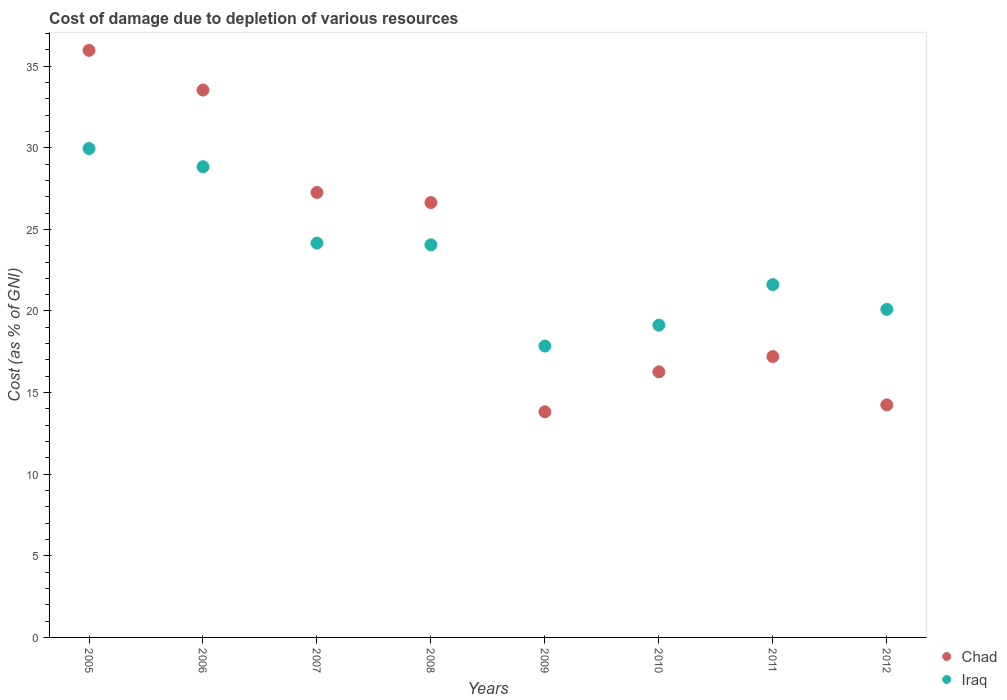Is the number of dotlines equal to the number of legend labels?
Keep it short and to the point. Yes. What is the cost of damage caused due to the depletion of various resources in Chad in 2005?
Your response must be concise. 35.97. Across all years, what is the maximum cost of damage caused due to the depletion of various resources in Iraq?
Your answer should be very brief. 29.95. Across all years, what is the minimum cost of damage caused due to the depletion of various resources in Chad?
Your answer should be very brief. 13.82. What is the total cost of damage caused due to the depletion of various resources in Chad in the graph?
Ensure brevity in your answer.  184.96. What is the difference between the cost of damage caused due to the depletion of various resources in Iraq in 2005 and that in 2006?
Provide a short and direct response. 1.12. What is the difference between the cost of damage caused due to the depletion of various resources in Iraq in 2011 and the cost of damage caused due to the depletion of various resources in Chad in 2007?
Offer a very short reply. -5.64. What is the average cost of damage caused due to the depletion of various resources in Chad per year?
Your response must be concise. 23.12. In the year 2005, what is the difference between the cost of damage caused due to the depletion of various resources in Iraq and cost of damage caused due to the depletion of various resources in Chad?
Ensure brevity in your answer.  -6.02. In how many years, is the cost of damage caused due to the depletion of various resources in Iraq greater than 20 %?
Offer a very short reply. 6. What is the ratio of the cost of damage caused due to the depletion of various resources in Chad in 2009 to that in 2011?
Give a very brief answer. 0.8. Is the cost of damage caused due to the depletion of various resources in Iraq in 2006 less than that in 2012?
Your response must be concise. No. What is the difference between the highest and the second highest cost of damage caused due to the depletion of various resources in Iraq?
Your answer should be very brief. 1.12. What is the difference between the highest and the lowest cost of damage caused due to the depletion of various resources in Iraq?
Provide a short and direct response. 12.1. In how many years, is the cost of damage caused due to the depletion of various resources in Iraq greater than the average cost of damage caused due to the depletion of various resources in Iraq taken over all years?
Your answer should be very brief. 4. Is the sum of the cost of damage caused due to the depletion of various resources in Chad in 2007 and 2009 greater than the maximum cost of damage caused due to the depletion of various resources in Iraq across all years?
Make the answer very short. Yes. Is the cost of damage caused due to the depletion of various resources in Chad strictly less than the cost of damage caused due to the depletion of various resources in Iraq over the years?
Keep it short and to the point. No. How many dotlines are there?
Your answer should be compact. 2. How many years are there in the graph?
Make the answer very short. 8. What is the difference between two consecutive major ticks on the Y-axis?
Your answer should be compact. 5. Are the values on the major ticks of Y-axis written in scientific E-notation?
Offer a very short reply. No. Where does the legend appear in the graph?
Give a very brief answer. Bottom right. How many legend labels are there?
Your response must be concise. 2. What is the title of the graph?
Your answer should be compact. Cost of damage due to depletion of various resources. Does "Morocco" appear as one of the legend labels in the graph?
Make the answer very short. No. What is the label or title of the X-axis?
Your answer should be compact. Years. What is the label or title of the Y-axis?
Your answer should be compact. Cost (as % of GNI). What is the Cost (as % of GNI) in Chad in 2005?
Provide a short and direct response. 35.97. What is the Cost (as % of GNI) of Iraq in 2005?
Offer a very short reply. 29.95. What is the Cost (as % of GNI) of Chad in 2006?
Keep it short and to the point. 33.53. What is the Cost (as % of GNI) in Iraq in 2006?
Provide a succinct answer. 28.84. What is the Cost (as % of GNI) of Chad in 2007?
Offer a very short reply. 27.26. What is the Cost (as % of GNI) in Iraq in 2007?
Make the answer very short. 24.16. What is the Cost (as % of GNI) in Chad in 2008?
Keep it short and to the point. 26.64. What is the Cost (as % of GNI) of Iraq in 2008?
Give a very brief answer. 24.06. What is the Cost (as % of GNI) in Chad in 2009?
Offer a terse response. 13.82. What is the Cost (as % of GNI) of Iraq in 2009?
Your answer should be compact. 17.85. What is the Cost (as % of GNI) in Chad in 2010?
Your response must be concise. 16.27. What is the Cost (as % of GNI) of Iraq in 2010?
Your answer should be compact. 19.13. What is the Cost (as % of GNI) of Chad in 2011?
Your response must be concise. 17.21. What is the Cost (as % of GNI) of Iraq in 2011?
Give a very brief answer. 21.62. What is the Cost (as % of GNI) in Chad in 2012?
Offer a very short reply. 14.25. What is the Cost (as % of GNI) in Iraq in 2012?
Give a very brief answer. 20.1. Across all years, what is the maximum Cost (as % of GNI) of Chad?
Offer a very short reply. 35.97. Across all years, what is the maximum Cost (as % of GNI) of Iraq?
Offer a terse response. 29.95. Across all years, what is the minimum Cost (as % of GNI) of Chad?
Make the answer very short. 13.82. Across all years, what is the minimum Cost (as % of GNI) of Iraq?
Provide a succinct answer. 17.85. What is the total Cost (as % of GNI) in Chad in the graph?
Your answer should be very brief. 184.96. What is the total Cost (as % of GNI) of Iraq in the graph?
Your answer should be compact. 185.71. What is the difference between the Cost (as % of GNI) of Chad in 2005 and that in 2006?
Make the answer very short. 2.43. What is the difference between the Cost (as % of GNI) in Iraq in 2005 and that in 2006?
Your answer should be compact. 1.12. What is the difference between the Cost (as % of GNI) in Chad in 2005 and that in 2007?
Your response must be concise. 8.71. What is the difference between the Cost (as % of GNI) of Iraq in 2005 and that in 2007?
Your answer should be compact. 5.79. What is the difference between the Cost (as % of GNI) of Chad in 2005 and that in 2008?
Your response must be concise. 9.33. What is the difference between the Cost (as % of GNI) in Iraq in 2005 and that in 2008?
Provide a short and direct response. 5.9. What is the difference between the Cost (as % of GNI) of Chad in 2005 and that in 2009?
Your response must be concise. 22.15. What is the difference between the Cost (as % of GNI) in Iraq in 2005 and that in 2009?
Your answer should be very brief. 12.1. What is the difference between the Cost (as % of GNI) in Chad in 2005 and that in 2010?
Provide a short and direct response. 19.7. What is the difference between the Cost (as % of GNI) in Iraq in 2005 and that in 2010?
Give a very brief answer. 10.82. What is the difference between the Cost (as % of GNI) of Chad in 2005 and that in 2011?
Keep it short and to the point. 18.76. What is the difference between the Cost (as % of GNI) in Iraq in 2005 and that in 2011?
Provide a short and direct response. 8.34. What is the difference between the Cost (as % of GNI) of Chad in 2005 and that in 2012?
Make the answer very short. 21.72. What is the difference between the Cost (as % of GNI) in Iraq in 2005 and that in 2012?
Make the answer very short. 9.85. What is the difference between the Cost (as % of GNI) in Chad in 2006 and that in 2007?
Keep it short and to the point. 6.27. What is the difference between the Cost (as % of GNI) of Iraq in 2006 and that in 2007?
Ensure brevity in your answer.  4.68. What is the difference between the Cost (as % of GNI) of Chad in 2006 and that in 2008?
Provide a succinct answer. 6.89. What is the difference between the Cost (as % of GNI) in Iraq in 2006 and that in 2008?
Offer a very short reply. 4.78. What is the difference between the Cost (as % of GNI) of Chad in 2006 and that in 2009?
Offer a terse response. 19.71. What is the difference between the Cost (as % of GNI) of Iraq in 2006 and that in 2009?
Make the answer very short. 10.99. What is the difference between the Cost (as % of GNI) of Chad in 2006 and that in 2010?
Ensure brevity in your answer.  17.26. What is the difference between the Cost (as % of GNI) of Iraq in 2006 and that in 2010?
Offer a terse response. 9.71. What is the difference between the Cost (as % of GNI) of Chad in 2006 and that in 2011?
Offer a very short reply. 16.33. What is the difference between the Cost (as % of GNI) of Iraq in 2006 and that in 2011?
Your answer should be very brief. 7.22. What is the difference between the Cost (as % of GNI) in Chad in 2006 and that in 2012?
Provide a short and direct response. 19.29. What is the difference between the Cost (as % of GNI) in Iraq in 2006 and that in 2012?
Give a very brief answer. 8.74. What is the difference between the Cost (as % of GNI) in Chad in 2007 and that in 2008?
Ensure brevity in your answer.  0.62. What is the difference between the Cost (as % of GNI) of Iraq in 2007 and that in 2008?
Your response must be concise. 0.11. What is the difference between the Cost (as % of GNI) in Chad in 2007 and that in 2009?
Ensure brevity in your answer.  13.44. What is the difference between the Cost (as % of GNI) in Iraq in 2007 and that in 2009?
Your answer should be compact. 6.31. What is the difference between the Cost (as % of GNI) in Chad in 2007 and that in 2010?
Your answer should be compact. 10.99. What is the difference between the Cost (as % of GNI) of Iraq in 2007 and that in 2010?
Your answer should be very brief. 5.03. What is the difference between the Cost (as % of GNI) in Chad in 2007 and that in 2011?
Your answer should be compact. 10.06. What is the difference between the Cost (as % of GNI) in Iraq in 2007 and that in 2011?
Offer a terse response. 2.54. What is the difference between the Cost (as % of GNI) of Chad in 2007 and that in 2012?
Offer a very short reply. 13.02. What is the difference between the Cost (as % of GNI) of Iraq in 2007 and that in 2012?
Your response must be concise. 4.06. What is the difference between the Cost (as % of GNI) of Chad in 2008 and that in 2009?
Offer a terse response. 12.82. What is the difference between the Cost (as % of GNI) in Iraq in 2008 and that in 2009?
Your answer should be very brief. 6.21. What is the difference between the Cost (as % of GNI) in Chad in 2008 and that in 2010?
Offer a terse response. 10.37. What is the difference between the Cost (as % of GNI) in Iraq in 2008 and that in 2010?
Offer a terse response. 4.93. What is the difference between the Cost (as % of GNI) of Chad in 2008 and that in 2011?
Give a very brief answer. 9.44. What is the difference between the Cost (as % of GNI) in Iraq in 2008 and that in 2011?
Provide a short and direct response. 2.44. What is the difference between the Cost (as % of GNI) of Chad in 2008 and that in 2012?
Ensure brevity in your answer.  12.4. What is the difference between the Cost (as % of GNI) of Iraq in 2008 and that in 2012?
Ensure brevity in your answer.  3.96. What is the difference between the Cost (as % of GNI) of Chad in 2009 and that in 2010?
Give a very brief answer. -2.45. What is the difference between the Cost (as % of GNI) of Iraq in 2009 and that in 2010?
Offer a very short reply. -1.28. What is the difference between the Cost (as % of GNI) of Chad in 2009 and that in 2011?
Your answer should be very brief. -3.38. What is the difference between the Cost (as % of GNI) of Iraq in 2009 and that in 2011?
Ensure brevity in your answer.  -3.77. What is the difference between the Cost (as % of GNI) of Chad in 2009 and that in 2012?
Offer a very short reply. -0.42. What is the difference between the Cost (as % of GNI) of Iraq in 2009 and that in 2012?
Offer a very short reply. -2.25. What is the difference between the Cost (as % of GNI) in Chad in 2010 and that in 2011?
Offer a very short reply. -0.94. What is the difference between the Cost (as % of GNI) of Iraq in 2010 and that in 2011?
Your answer should be very brief. -2.49. What is the difference between the Cost (as % of GNI) in Chad in 2010 and that in 2012?
Offer a terse response. 2.02. What is the difference between the Cost (as % of GNI) of Iraq in 2010 and that in 2012?
Keep it short and to the point. -0.97. What is the difference between the Cost (as % of GNI) of Chad in 2011 and that in 2012?
Keep it short and to the point. 2.96. What is the difference between the Cost (as % of GNI) of Iraq in 2011 and that in 2012?
Provide a succinct answer. 1.52. What is the difference between the Cost (as % of GNI) in Chad in 2005 and the Cost (as % of GNI) in Iraq in 2006?
Give a very brief answer. 7.13. What is the difference between the Cost (as % of GNI) in Chad in 2005 and the Cost (as % of GNI) in Iraq in 2007?
Provide a short and direct response. 11.81. What is the difference between the Cost (as % of GNI) in Chad in 2005 and the Cost (as % of GNI) in Iraq in 2008?
Offer a very short reply. 11.91. What is the difference between the Cost (as % of GNI) in Chad in 2005 and the Cost (as % of GNI) in Iraq in 2009?
Provide a short and direct response. 18.12. What is the difference between the Cost (as % of GNI) of Chad in 2005 and the Cost (as % of GNI) of Iraq in 2010?
Provide a succinct answer. 16.84. What is the difference between the Cost (as % of GNI) of Chad in 2005 and the Cost (as % of GNI) of Iraq in 2011?
Your response must be concise. 14.35. What is the difference between the Cost (as % of GNI) in Chad in 2005 and the Cost (as % of GNI) in Iraq in 2012?
Your answer should be compact. 15.87. What is the difference between the Cost (as % of GNI) in Chad in 2006 and the Cost (as % of GNI) in Iraq in 2007?
Your answer should be compact. 9.37. What is the difference between the Cost (as % of GNI) of Chad in 2006 and the Cost (as % of GNI) of Iraq in 2008?
Offer a terse response. 9.48. What is the difference between the Cost (as % of GNI) in Chad in 2006 and the Cost (as % of GNI) in Iraq in 2009?
Your response must be concise. 15.68. What is the difference between the Cost (as % of GNI) of Chad in 2006 and the Cost (as % of GNI) of Iraq in 2010?
Your response must be concise. 14.4. What is the difference between the Cost (as % of GNI) of Chad in 2006 and the Cost (as % of GNI) of Iraq in 2011?
Provide a succinct answer. 11.92. What is the difference between the Cost (as % of GNI) of Chad in 2006 and the Cost (as % of GNI) of Iraq in 2012?
Your response must be concise. 13.44. What is the difference between the Cost (as % of GNI) in Chad in 2007 and the Cost (as % of GNI) in Iraq in 2008?
Provide a succinct answer. 3.21. What is the difference between the Cost (as % of GNI) in Chad in 2007 and the Cost (as % of GNI) in Iraq in 2009?
Offer a very short reply. 9.41. What is the difference between the Cost (as % of GNI) of Chad in 2007 and the Cost (as % of GNI) of Iraq in 2010?
Offer a terse response. 8.13. What is the difference between the Cost (as % of GNI) of Chad in 2007 and the Cost (as % of GNI) of Iraq in 2011?
Offer a terse response. 5.64. What is the difference between the Cost (as % of GNI) of Chad in 2007 and the Cost (as % of GNI) of Iraq in 2012?
Offer a terse response. 7.16. What is the difference between the Cost (as % of GNI) of Chad in 2008 and the Cost (as % of GNI) of Iraq in 2009?
Provide a succinct answer. 8.79. What is the difference between the Cost (as % of GNI) of Chad in 2008 and the Cost (as % of GNI) of Iraq in 2010?
Your answer should be compact. 7.51. What is the difference between the Cost (as % of GNI) in Chad in 2008 and the Cost (as % of GNI) in Iraq in 2011?
Provide a succinct answer. 5.02. What is the difference between the Cost (as % of GNI) in Chad in 2008 and the Cost (as % of GNI) in Iraq in 2012?
Keep it short and to the point. 6.54. What is the difference between the Cost (as % of GNI) of Chad in 2009 and the Cost (as % of GNI) of Iraq in 2010?
Make the answer very short. -5.31. What is the difference between the Cost (as % of GNI) of Chad in 2009 and the Cost (as % of GNI) of Iraq in 2011?
Offer a terse response. -7.8. What is the difference between the Cost (as % of GNI) of Chad in 2009 and the Cost (as % of GNI) of Iraq in 2012?
Provide a succinct answer. -6.28. What is the difference between the Cost (as % of GNI) of Chad in 2010 and the Cost (as % of GNI) of Iraq in 2011?
Keep it short and to the point. -5.35. What is the difference between the Cost (as % of GNI) in Chad in 2010 and the Cost (as % of GNI) in Iraq in 2012?
Keep it short and to the point. -3.83. What is the difference between the Cost (as % of GNI) of Chad in 2011 and the Cost (as % of GNI) of Iraq in 2012?
Provide a succinct answer. -2.89. What is the average Cost (as % of GNI) of Chad per year?
Offer a very short reply. 23.12. What is the average Cost (as % of GNI) in Iraq per year?
Give a very brief answer. 23.21. In the year 2005, what is the difference between the Cost (as % of GNI) in Chad and Cost (as % of GNI) in Iraq?
Offer a terse response. 6.02. In the year 2006, what is the difference between the Cost (as % of GNI) in Chad and Cost (as % of GNI) in Iraq?
Provide a short and direct response. 4.7. In the year 2007, what is the difference between the Cost (as % of GNI) in Chad and Cost (as % of GNI) in Iraq?
Provide a short and direct response. 3.1. In the year 2008, what is the difference between the Cost (as % of GNI) of Chad and Cost (as % of GNI) of Iraq?
Your response must be concise. 2.59. In the year 2009, what is the difference between the Cost (as % of GNI) in Chad and Cost (as % of GNI) in Iraq?
Provide a succinct answer. -4.03. In the year 2010, what is the difference between the Cost (as % of GNI) of Chad and Cost (as % of GNI) of Iraq?
Provide a short and direct response. -2.86. In the year 2011, what is the difference between the Cost (as % of GNI) in Chad and Cost (as % of GNI) in Iraq?
Your answer should be compact. -4.41. In the year 2012, what is the difference between the Cost (as % of GNI) in Chad and Cost (as % of GNI) in Iraq?
Provide a succinct answer. -5.85. What is the ratio of the Cost (as % of GNI) in Chad in 2005 to that in 2006?
Offer a terse response. 1.07. What is the ratio of the Cost (as % of GNI) of Iraq in 2005 to that in 2006?
Your response must be concise. 1.04. What is the ratio of the Cost (as % of GNI) of Chad in 2005 to that in 2007?
Your answer should be very brief. 1.32. What is the ratio of the Cost (as % of GNI) of Iraq in 2005 to that in 2007?
Your response must be concise. 1.24. What is the ratio of the Cost (as % of GNI) of Chad in 2005 to that in 2008?
Offer a terse response. 1.35. What is the ratio of the Cost (as % of GNI) of Iraq in 2005 to that in 2008?
Give a very brief answer. 1.25. What is the ratio of the Cost (as % of GNI) in Chad in 2005 to that in 2009?
Your response must be concise. 2.6. What is the ratio of the Cost (as % of GNI) in Iraq in 2005 to that in 2009?
Ensure brevity in your answer.  1.68. What is the ratio of the Cost (as % of GNI) in Chad in 2005 to that in 2010?
Provide a succinct answer. 2.21. What is the ratio of the Cost (as % of GNI) of Iraq in 2005 to that in 2010?
Offer a terse response. 1.57. What is the ratio of the Cost (as % of GNI) in Chad in 2005 to that in 2011?
Give a very brief answer. 2.09. What is the ratio of the Cost (as % of GNI) of Iraq in 2005 to that in 2011?
Your answer should be very brief. 1.39. What is the ratio of the Cost (as % of GNI) of Chad in 2005 to that in 2012?
Your answer should be very brief. 2.52. What is the ratio of the Cost (as % of GNI) of Iraq in 2005 to that in 2012?
Your response must be concise. 1.49. What is the ratio of the Cost (as % of GNI) of Chad in 2006 to that in 2007?
Your answer should be compact. 1.23. What is the ratio of the Cost (as % of GNI) in Iraq in 2006 to that in 2007?
Your answer should be very brief. 1.19. What is the ratio of the Cost (as % of GNI) in Chad in 2006 to that in 2008?
Ensure brevity in your answer.  1.26. What is the ratio of the Cost (as % of GNI) in Iraq in 2006 to that in 2008?
Offer a terse response. 1.2. What is the ratio of the Cost (as % of GNI) in Chad in 2006 to that in 2009?
Make the answer very short. 2.43. What is the ratio of the Cost (as % of GNI) in Iraq in 2006 to that in 2009?
Ensure brevity in your answer.  1.62. What is the ratio of the Cost (as % of GNI) in Chad in 2006 to that in 2010?
Ensure brevity in your answer.  2.06. What is the ratio of the Cost (as % of GNI) of Iraq in 2006 to that in 2010?
Keep it short and to the point. 1.51. What is the ratio of the Cost (as % of GNI) of Chad in 2006 to that in 2011?
Your answer should be very brief. 1.95. What is the ratio of the Cost (as % of GNI) of Iraq in 2006 to that in 2011?
Give a very brief answer. 1.33. What is the ratio of the Cost (as % of GNI) in Chad in 2006 to that in 2012?
Make the answer very short. 2.35. What is the ratio of the Cost (as % of GNI) of Iraq in 2006 to that in 2012?
Your answer should be very brief. 1.43. What is the ratio of the Cost (as % of GNI) in Chad in 2007 to that in 2008?
Keep it short and to the point. 1.02. What is the ratio of the Cost (as % of GNI) in Iraq in 2007 to that in 2008?
Provide a succinct answer. 1. What is the ratio of the Cost (as % of GNI) in Chad in 2007 to that in 2009?
Your response must be concise. 1.97. What is the ratio of the Cost (as % of GNI) in Iraq in 2007 to that in 2009?
Offer a very short reply. 1.35. What is the ratio of the Cost (as % of GNI) of Chad in 2007 to that in 2010?
Offer a very short reply. 1.68. What is the ratio of the Cost (as % of GNI) in Iraq in 2007 to that in 2010?
Provide a succinct answer. 1.26. What is the ratio of the Cost (as % of GNI) in Chad in 2007 to that in 2011?
Offer a very short reply. 1.58. What is the ratio of the Cost (as % of GNI) in Iraq in 2007 to that in 2011?
Provide a short and direct response. 1.12. What is the ratio of the Cost (as % of GNI) of Chad in 2007 to that in 2012?
Your answer should be compact. 1.91. What is the ratio of the Cost (as % of GNI) of Iraq in 2007 to that in 2012?
Provide a succinct answer. 1.2. What is the ratio of the Cost (as % of GNI) in Chad in 2008 to that in 2009?
Your answer should be compact. 1.93. What is the ratio of the Cost (as % of GNI) in Iraq in 2008 to that in 2009?
Offer a very short reply. 1.35. What is the ratio of the Cost (as % of GNI) in Chad in 2008 to that in 2010?
Provide a succinct answer. 1.64. What is the ratio of the Cost (as % of GNI) in Iraq in 2008 to that in 2010?
Keep it short and to the point. 1.26. What is the ratio of the Cost (as % of GNI) of Chad in 2008 to that in 2011?
Make the answer very short. 1.55. What is the ratio of the Cost (as % of GNI) of Iraq in 2008 to that in 2011?
Offer a very short reply. 1.11. What is the ratio of the Cost (as % of GNI) of Chad in 2008 to that in 2012?
Offer a very short reply. 1.87. What is the ratio of the Cost (as % of GNI) in Iraq in 2008 to that in 2012?
Your response must be concise. 1.2. What is the ratio of the Cost (as % of GNI) of Chad in 2009 to that in 2010?
Provide a short and direct response. 0.85. What is the ratio of the Cost (as % of GNI) in Iraq in 2009 to that in 2010?
Ensure brevity in your answer.  0.93. What is the ratio of the Cost (as % of GNI) of Chad in 2009 to that in 2011?
Give a very brief answer. 0.8. What is the ratio of the Cost (as % of GNI) of Iraq in 2009 to that in 2011?
Ensure brevity in your answer.  0.83. What is the ratio of the Cost (as % of GNI) in Chad in 2009 to that in 2012?
Offer a very short reply. 0.97. What is the ratio of the Cost (as % of GNI) of Iraq in 2009 to that in 2012?
Your answer should be very brief. 0.89. What is the ratio of the Cost (as % of GNI) in Chad in 2010 to that in 2011?
Offer a very short reply. 0.95. What is the ratio of the Cost (as % of GNI) of Iraq in 2010 to that in 2011?
Provide a short and direct response. 0.88. What is the ratio of the Cost (as % of GNI) of Chad in 2010 to that in 2012?
Make the answer very short. 1.14. What is the ratio of the Cost (as % of GNI) of Iraq in 2010 to that in 2012?
Offer a terse response. 0.95. What is the ratio of the Cost (as % of GNI) in Chad in 2011 to that in 2012?
Provide a succinct answer. 1.21. What is the ratio of the Cost (as % of GNI) of Iraq in 2011 to that in 2012?
Provide a succinct answer. 1.08. What is the difference between the highest and the second highest Cost (as % of GNI) in Chad?
Offer a terse response. 2.43. What is the difference between the highest and the second highest Cost (as % of GNI) in Iraq?
Ensure brevity in your answer.  1.12. What is the difference between the highest and the lowest Cost (as % of GNI) of Chad?
Ensure brevity in your answer.  22.15. What is the difference between the highest and the lowest Cost (as % of GNI) in Iraq?
Your answer should be compact. 12.1. 